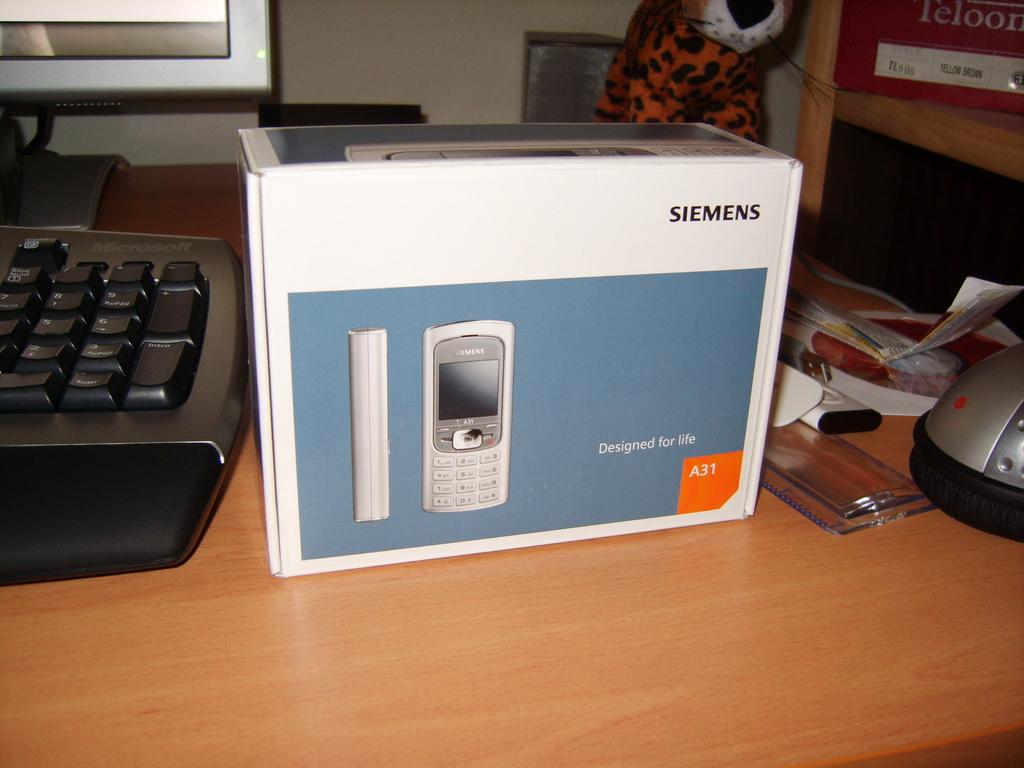What object is located on the table in the foreground of the image? There is a box on a table in the foreground of the image. What can be seen on the right side of the image? There is a scale, a cable, and a shelf on the right side of the image. What electronic devices are visible on the left side of the image? There is a keyboard and a monitor on the left side of the image. What is placed on top of the objects in the image? There is a toy on top of the objects in the image. What month is depicted on the calendar in the image? There is no calendar present in the image, so it is not possible to determine the month. How many thumbs are visible in the image? There are no thumbs visible in the image. 